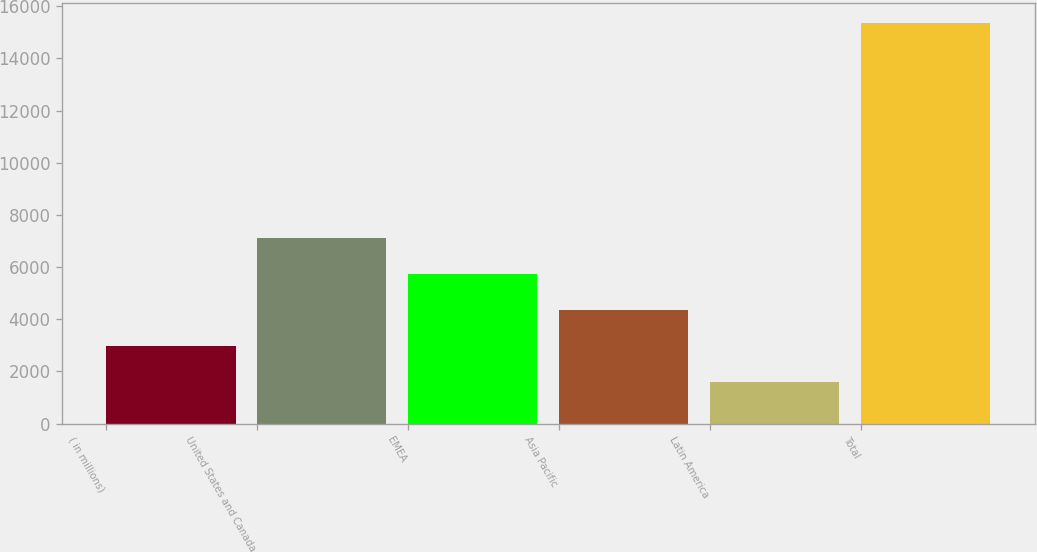Convert chart to OTSL. <chart><loc_0><loc_0><loc_500><loc_500><bar_chart><fcel>( in millions)<fcel>United States and Canada<fcel>EMEA<fcel>Asia Pacific<fcel>Latin America<fcel>Total<nl><fcel>2971.1<fcel>7105.4<fcel>5727.3<fcel>4349.2<fcel>1593<fcel>15374<nl></chart> 